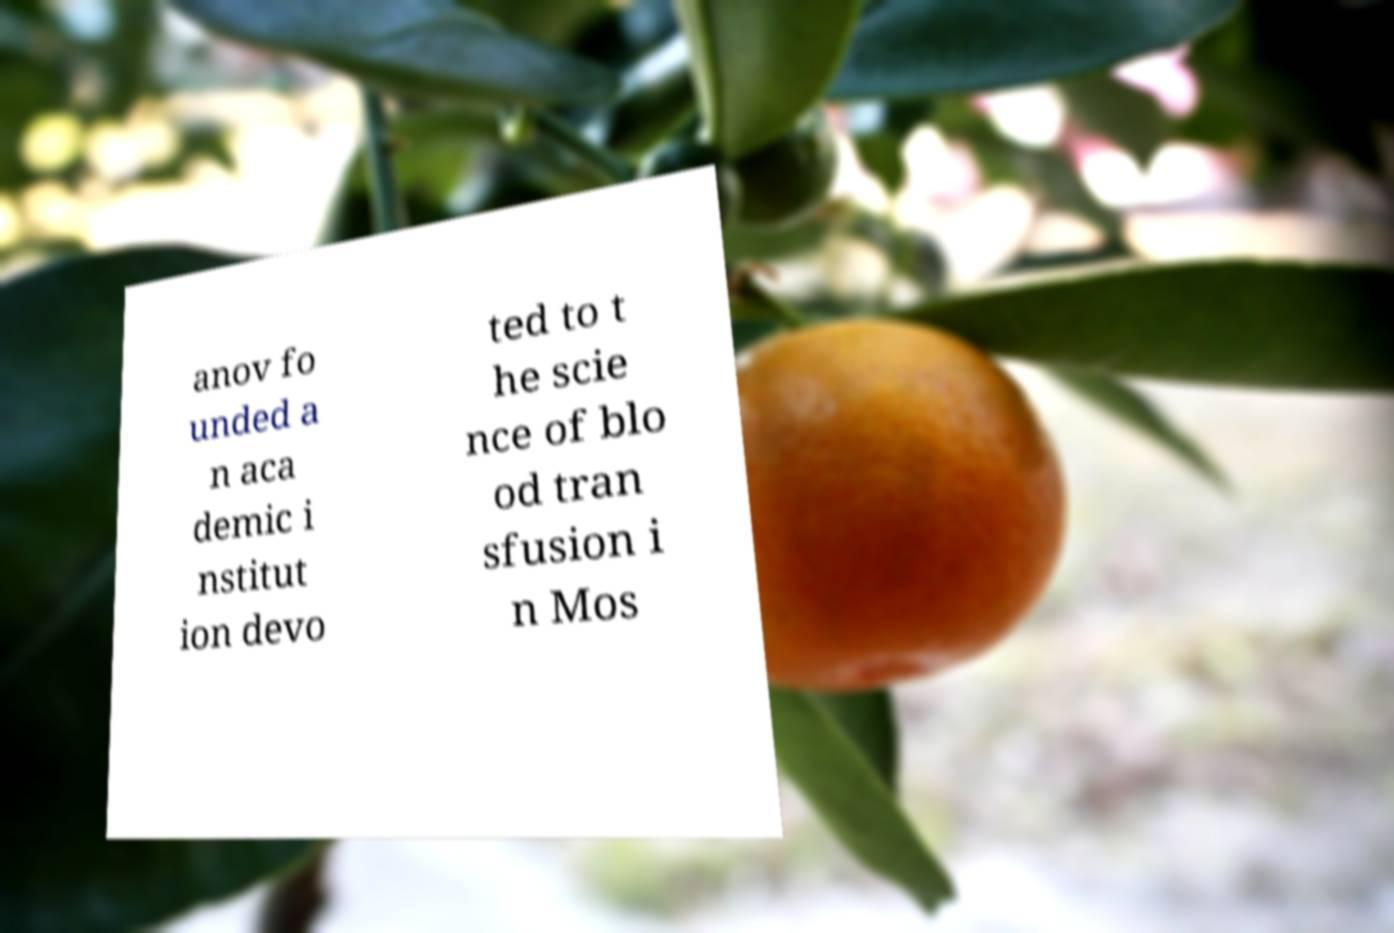Could you extract and type out the text from this image? anov fo unded a n aca demic i nstitut ion devo ted to t he scie nce of blo od tran sfusion i n Mos 